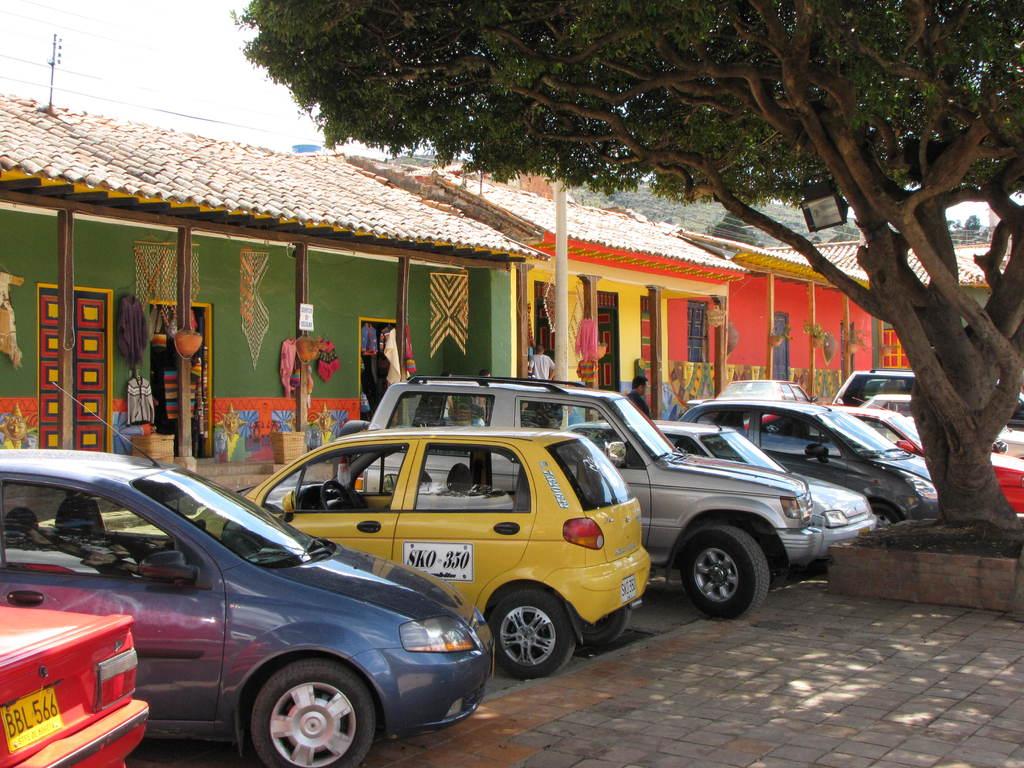What three letters are found on the licence plate of the red car?
Your answer should be very brief. Bbl. 